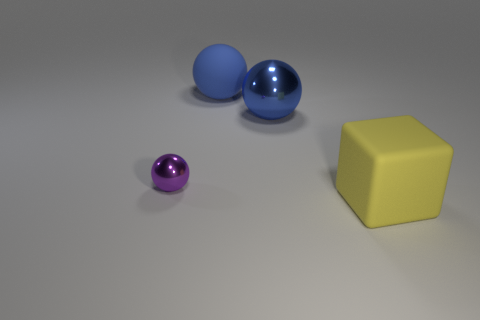Is the matte block the same color as the matte ball?
Keep it short and to the point. No. How many big matte things have the same color as the big metallic object?
Ensure brevity in your answer.  1. What is the material of the tiny purple thing?
Make the answer very short. Metal. What color is the large object that is made of the same material as the tiny purple sphere?
Offer a terse response. Blue. Is there a yellow matte block that is on the right side of the rubber object behind the block?
Offer a terse response. Yes. How many other things are the same shape as the yellow object?
Make the answer very short. 0. There is a large matte object that is left of the yellow object; is its shape the same as the metal object to the right of the tiny purple ball?
Your response must be concise. Yes. There is a metallic thing that is left of the big rubber object that is behind the yellow cube; what number of blue metallic objects are in front of it?
Offer a very short reply. 0. What color is the large rubber block?
Your response must be concise. Yellow. What number of other things are the same size as the purple ball?
Your response must be concise. 0. 